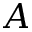<formula> <loc_0><loc_0><loc_500><loc_500>A</formula> 